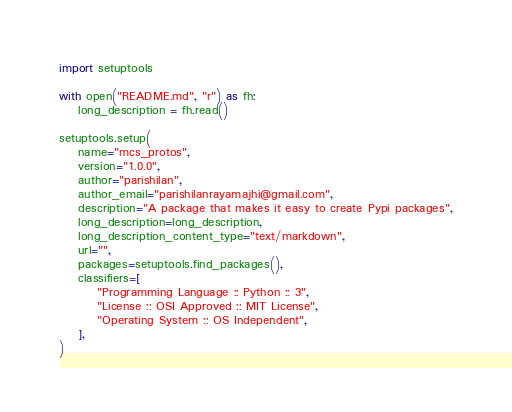<code> <loc_0><loc_0><loc_500><loc_500><_Python_>
import setuptools

with open("README.md", "r") as fh:
    long_description = fh.read()

setuptools.setup(
    name="mcs_protos",
    version="1.0.0",
    author="parishilan",
    author_email="parishilanrayamajhi@gmail.com",
    description="A package that makes it easy to create Pypi packages",
    long_description=long_description,
    long_description_content_type="text/markdown",
    url="",
    packages=setuptools.find_packages(),
    classifiers=[
        "Programming Language :: Python :: 3",
        "License :: OSI Approved :: MIT License",
        "Operating System :: OS Independent",
    ],
) 
</code> 